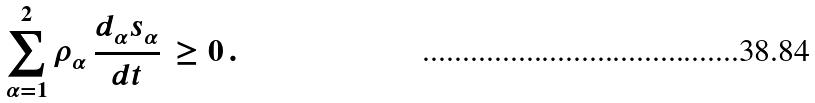Convert formula to latex. <formula><loc_0><loc_0><loc_500><loc_500>\sum _ { \alpha = 1 } ^ { 2 } \rho _ { \alpha } \, \frac { d _ { \alpha } s _ { \alpha } } { d t } \, \geq 0 \, .</formula> 